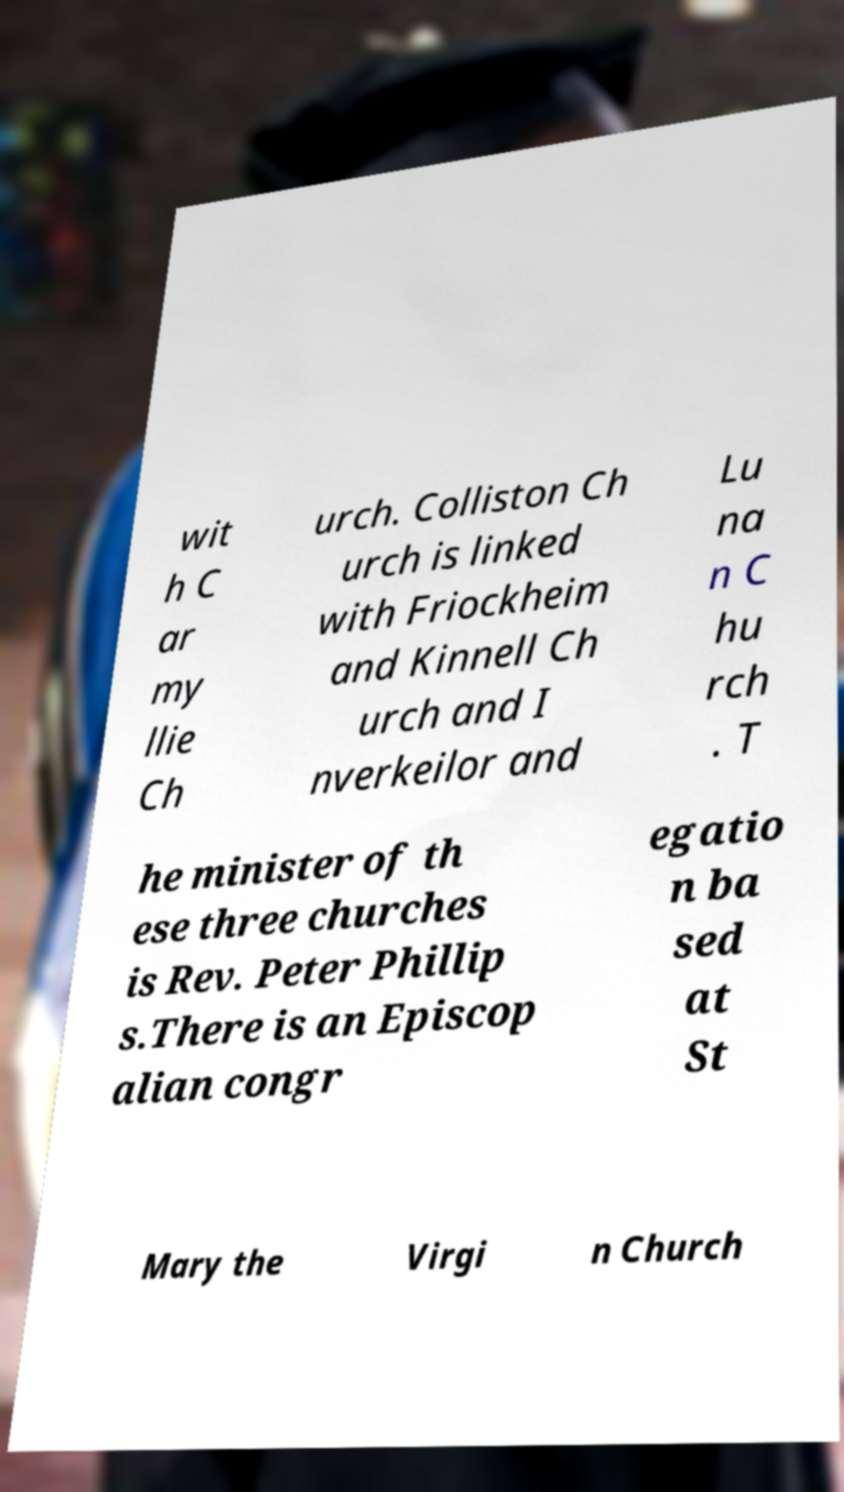Please identify and transcribe the text found in this image. wit h C ar my llie Ch urch. Colliston Ch urch is linked with Friockheim and Kinnell Ch urch and I nverkeilor and Lu na n C hu rch . T he minister of th ese three churches is Rev. Peter Phillip s.There is an Episcop alian congr egatio n ba sed at St Mary the Virgi n Church 